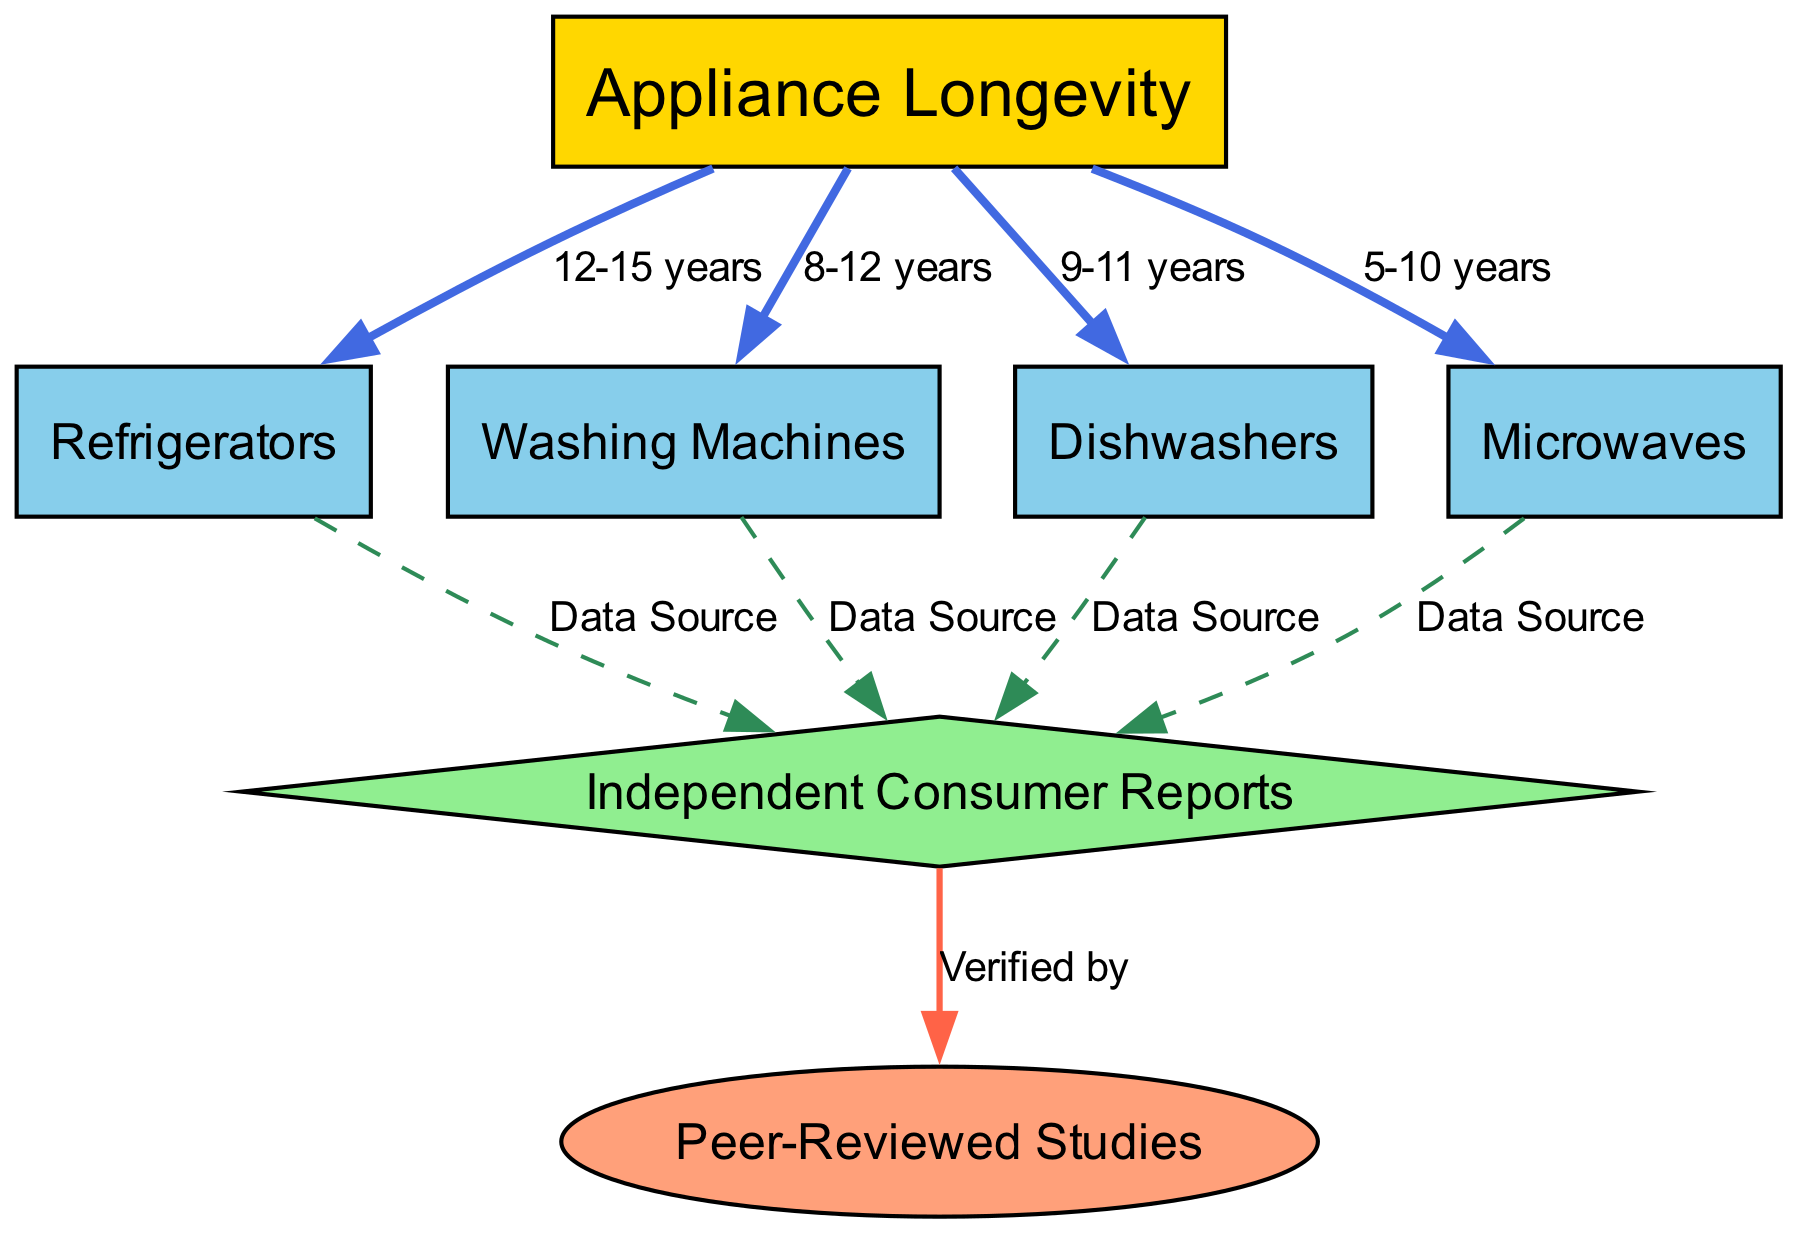What is the longevity range of Refrigerators? The diagram shows an edge from the node "Appliance Longevity" to "Refrigerators" labeled "12-15 years." This indicates that the longevity of Refrigerators ranges from 12 to 15 years.
Answer: 12-15 years What is the data source for Dishwashers? The diagram has an edge from "Dishwashers" to "Independent Consumer Reports" labeled "Data Source." This shows that the data for Dishwashers is sourced from Independent Consumer Reports.
Answer: Data Source Which appliance has the shortest longevity range? The edges indicate that Microwaves have a longevity range of "5-10 years," which is shorter than the other appliances listed.
Answer: 5-10 years How many appliances are listed in the diagram? There are four appliances represented in the nodes: Refrigerators, Washing Machines, Dishwashers, and Microwaves. Counting them gives a total of four appliances.
Answer: 4 What type of studies verify the data in the diagram? The diagram shows an edge from "Independent Consumer Reports" to "Peer-Reviewed Studies," labeled "Verified by." This indicates that the data provided is verified by Peer-Reviewed Studies.
Answer: Peer-Reviewed Studies What is the longevity of Washing Machines according to the diagram? An edge from "Appliance Longevity" to "Washing Machines" is labeled "8-12 years," which provides the longevity range for Washing Machines.
Answer: 8-12 years Which appliance has a longevity range that is the same as Dishwashers? The edge for Dishwashers states a longevity range of "9-11 years." The diagram does not indicate any other appliances with the same range, so we conclude that no appliance shares this exact range.
Answer: None What is the longest longevity range among the appliances? The edge for Refrigerators shows a longevity range of "12-15 years." Since this is the longest range listed, it indicates that Refrigerators have the longest longevity among the appliances.
Answer: 12-15 years 